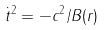Convert formula to latex. <formula><loc_0><loc_0><loc_500><loc_500>\dot { t } ^ { 2 } = - c ^ { 2 } / B ( r )</formula> 